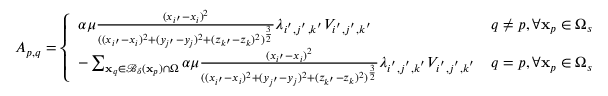<formula> <loc_0><loc_0><loc_500><loc_500>A _ { p , q } = \left \{ \begin{array} { l l } { \alpha \mu \frac { ( x _ { i ^ { \prime } } - x _ { i } ) ^ { 2 } } { ( ( x _ { i ^ { \prime } } - x _ { i } ) ^ { 2 } + ( y _ { j ^ { \prime } } - y _ { j } ) ^ { 2 } + ( z _ { k ^ { \prime } } - z _ { k } ) ^ { 2 } ) ^ { \frac { 3 } { 2 } } } \lambda _ { i ^ { ^ { \prime } } , j ^ { ^ { \prime } } , k ^ { ^ { \prime } } } V _ { i ^ { ^ { \prime } } , j ^ { ^ { \prime } } , k ^ { ^ { \prime } } } } & { q \neq p , \forall x _ { p } \in \Omega _ { s } } \\ { - \sum _ { x _ { q } \in \mathcal { B } _ { \delta } ( x _ { p } ) \cap \Omega } \alpha \mu \frac { ( x _ { i ^ { \prime } } - x _ { i } ) ^ { 2 } } { ( ( x _ { i ^ { \prime } } - x _ { i } ) ^ { 2 } + ( y _ { j ^ { \prime } } - y _ { j } ) ^ { 2 } + ( z _ { k ^ { \prime } } - z _ { k } ) ^ { 2 } ) ^ { \frac { 3 } { 2 } } } \lambda _ { i ^ { ^ { \prime } } , j ^ { ^ { \prime } } , k ^ { ^ { \prime } } } V _ { i ^ { ^ { \prime } } , j ^ { ^ { \prime } } , k ^ { ^ { \prime } } } } & { q = p , \forall x _ { p } \in \Omega _ { s } } \end{array}</formula> 